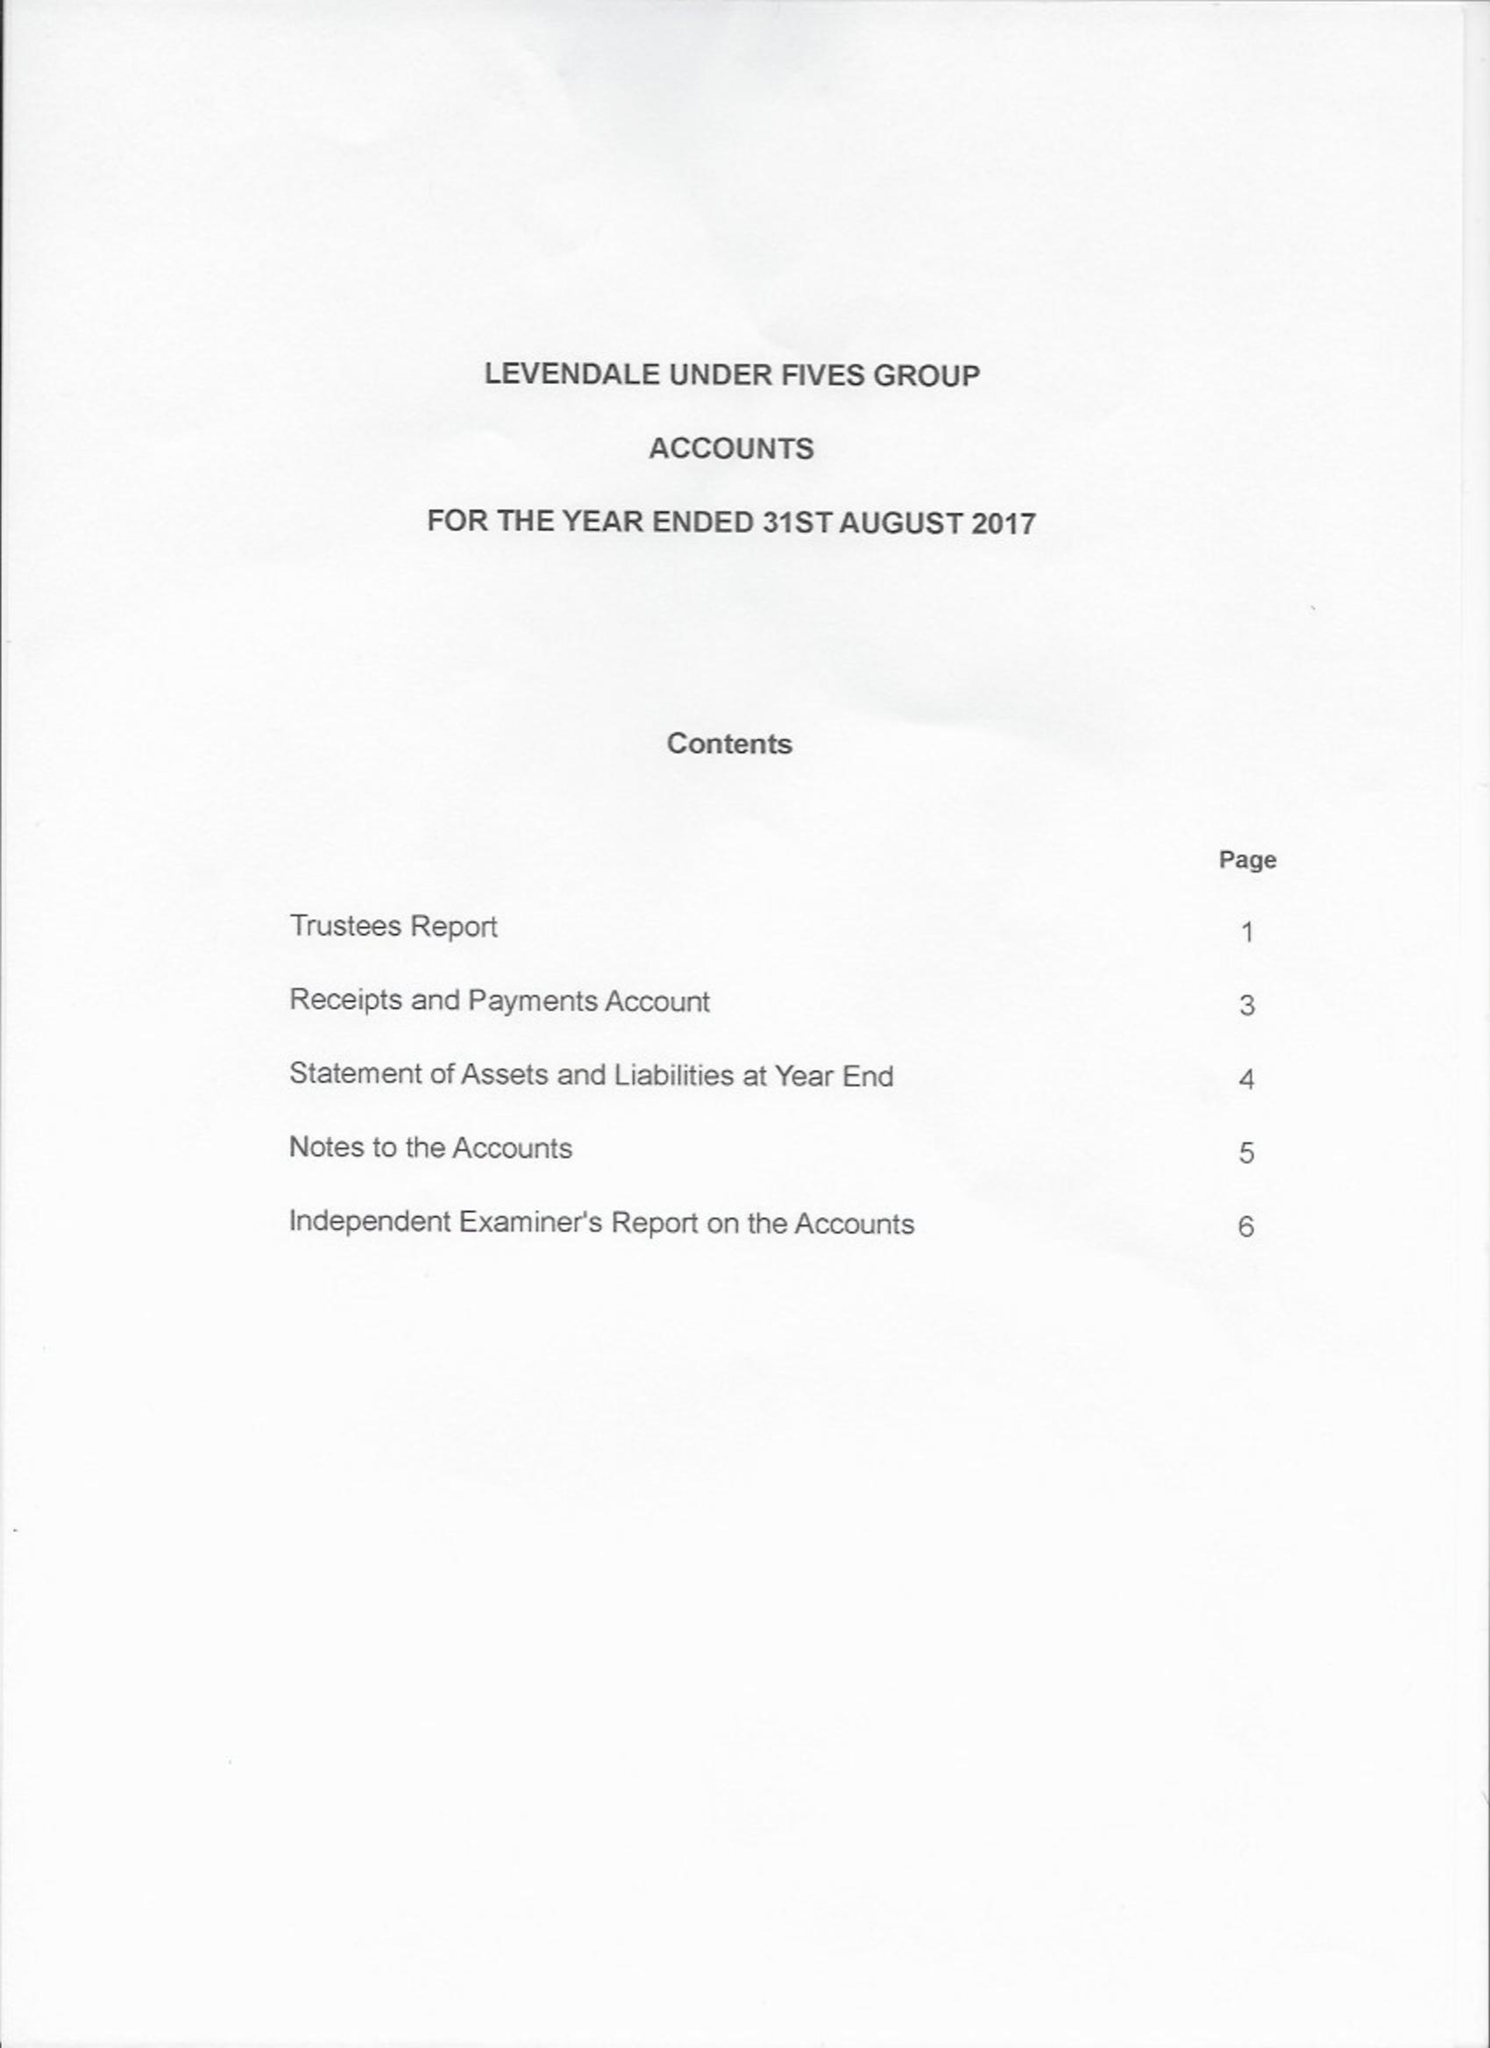What is the value for the charity_number?
Answer the question using a single word or phrase. 506722 